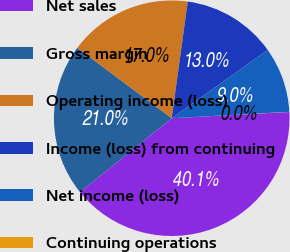Convert chart to OTSL. <chart><loc_0><loc_0><loc_500><loc_500><pie_chart><fcel>Net sales<fcel>Gross margin<fcel>Operating income (loss)<fcel>Income (loss) from continuing<fcel>Net income (loss)<fcel>Continuing operations<nl><fcel>40.06%<fcel>20.99%<fcel>16.98%<fcel>12.98%<fcel>8.98%<fcel>0.02%<nl></chart> 